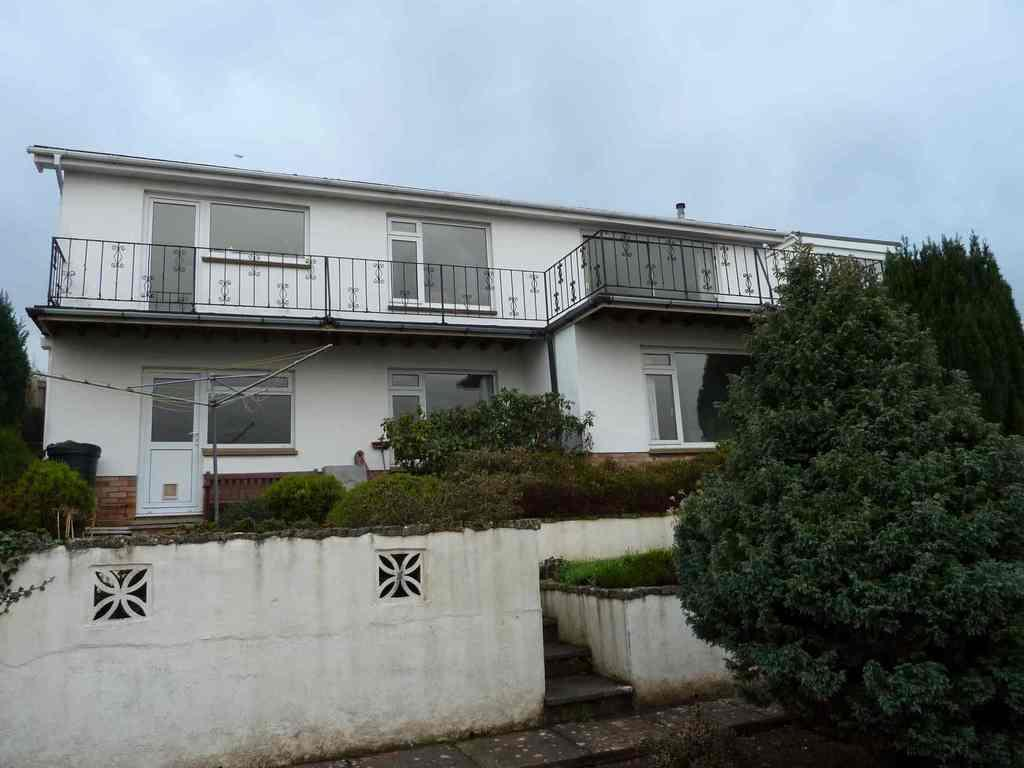What type of structure is shown in the image? The image depicts a house. What can be seen in front of the house? There is a lot of greenery and trees in front of the house. What is visible in the background of the image? The sky is visible in the background of the image. What type of drug is being used in the image? There is no drug present in the image; it depicts a house with greenery and trees in front of it. 